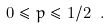<formula> <loc_0><loc_0><loc_500><loc_500>0 \leq p \leq 1 / 2 \ .</formula> 